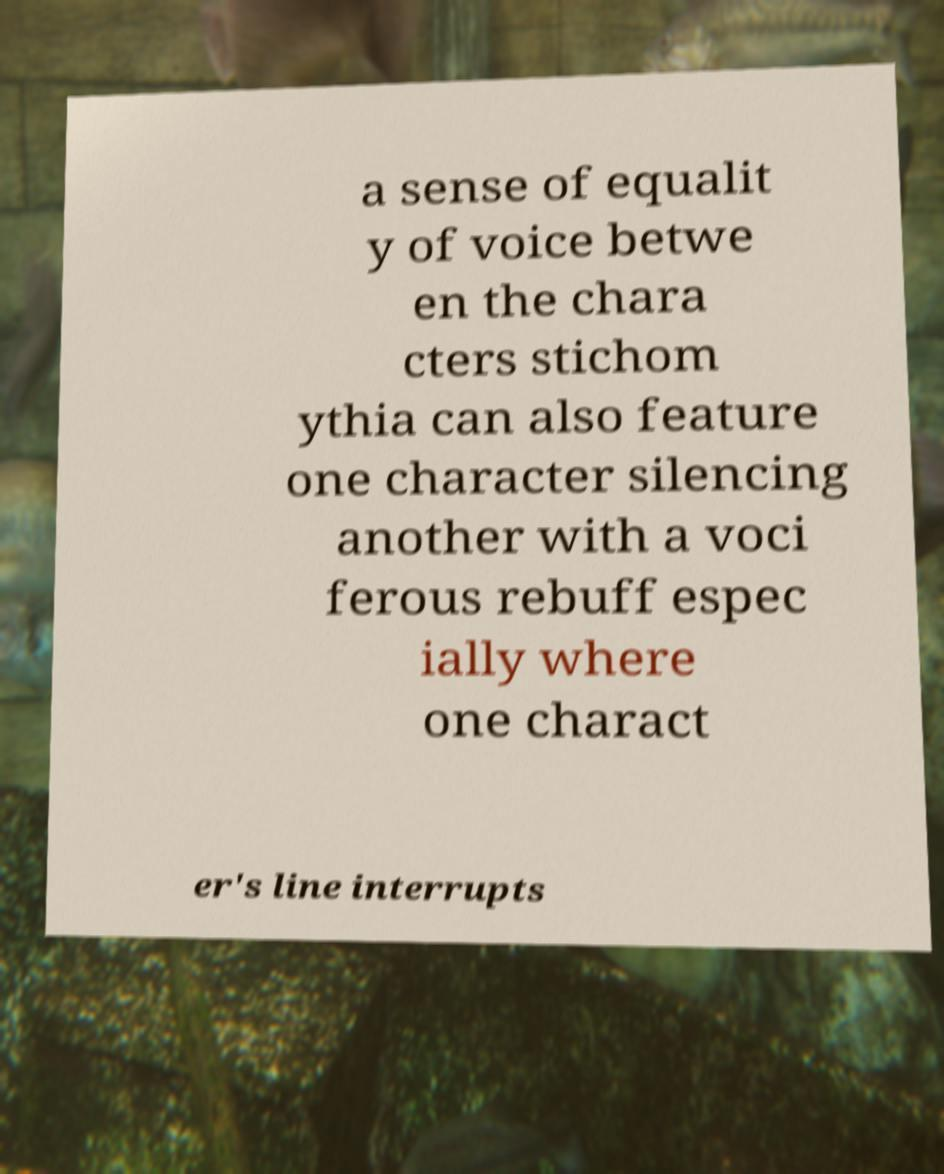Please identify and transcribe the text found in this image. a sense of equalit y of voice betwe en the chara cters stichom ythia can also feature one character silencing another with a voci ferous rebuff espec ially where one charact er's line interrupts 